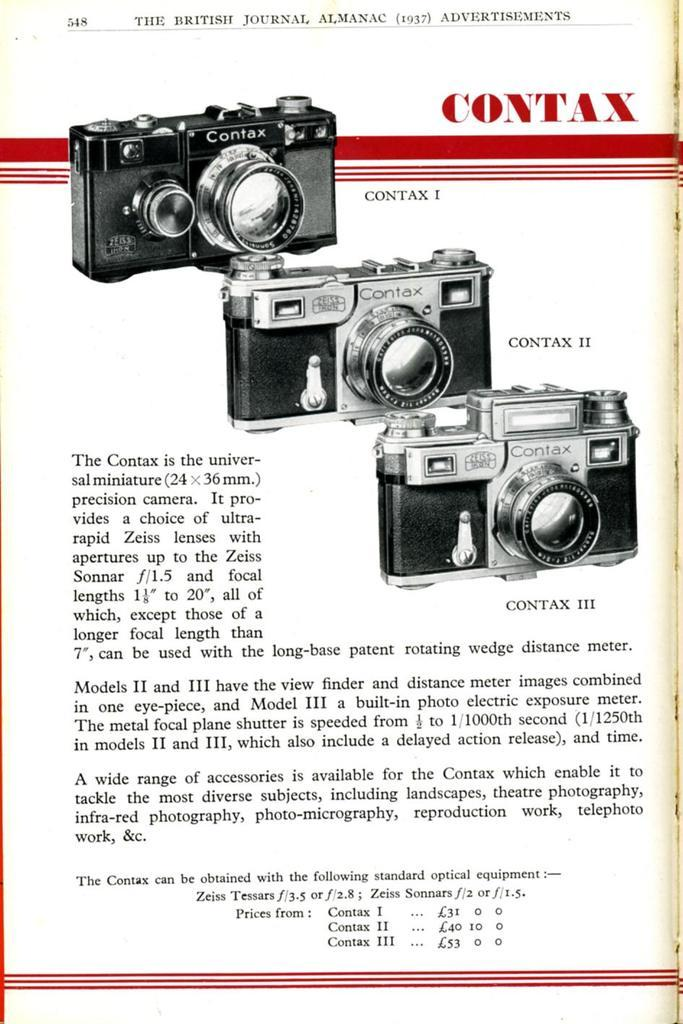Provide a one-sentence caption for the provided image. an old magazine add of a contax camera that shows different types of it. 